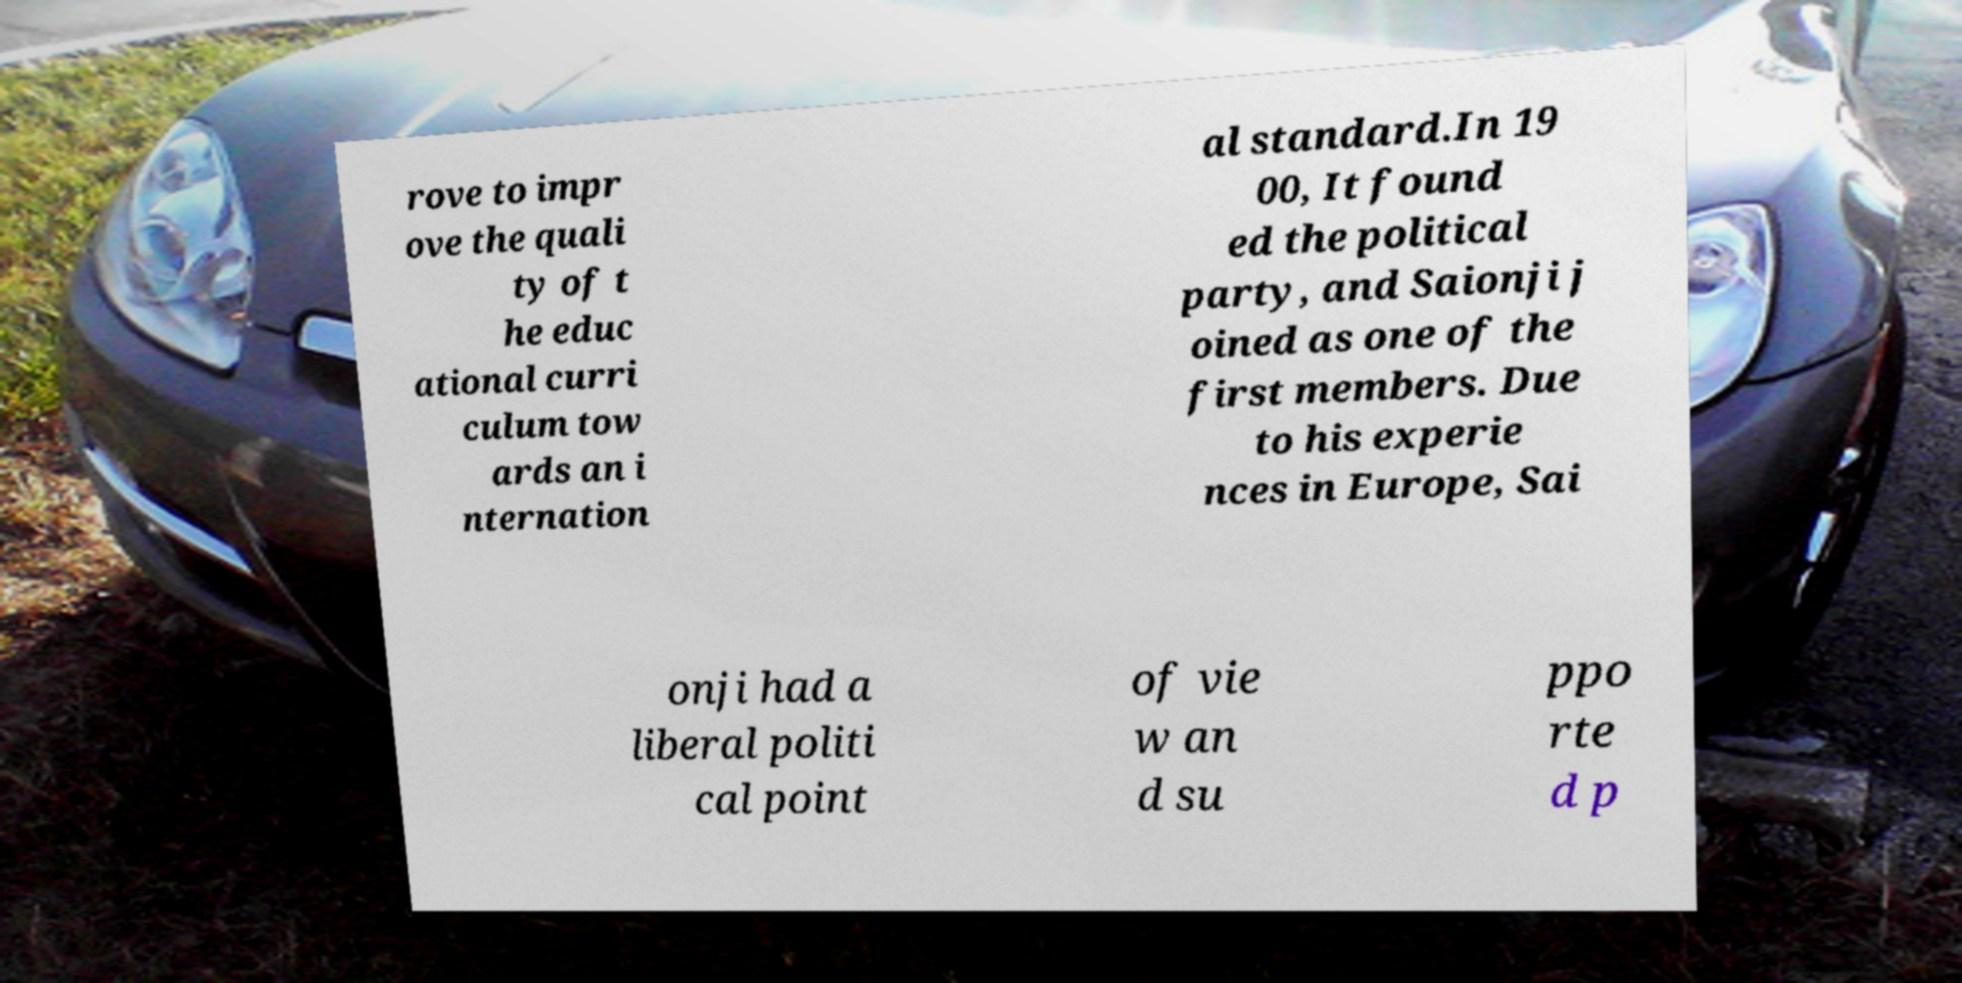Could you assist in decoding the text presented in this image and type it out clearly? rove to impr ove the quali ty of t he educ ational curri culum tow ards an i nternation al standard.In 19 00, It found ed the political party, and Saionji j oined as one of the first members. Due to his experie nces in Europe, Sai onji had a liberal politi cal point of vie w an d su ppo rte d p 